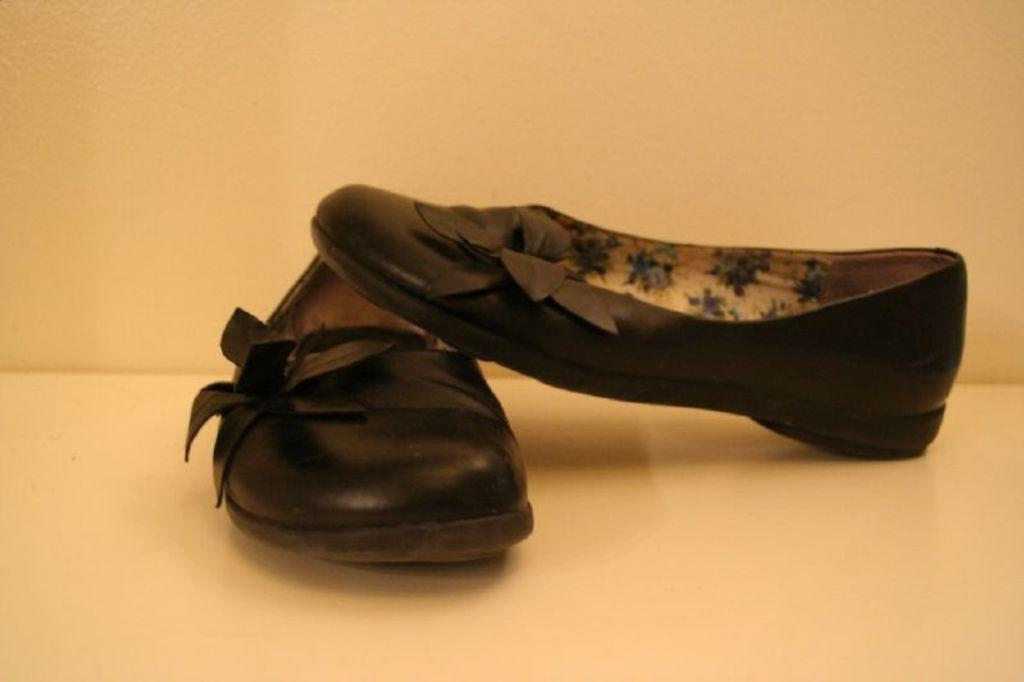What type of footwear is visible in the image? There are shoes in the image. What color are the shoes? The shoes are black in color. What is the color of the background in the image? The background of the image is cream-colored. What type of pleasure can be seen in the image? There is no pleasure visible in the image; it features shoes and a cream-colored background. 